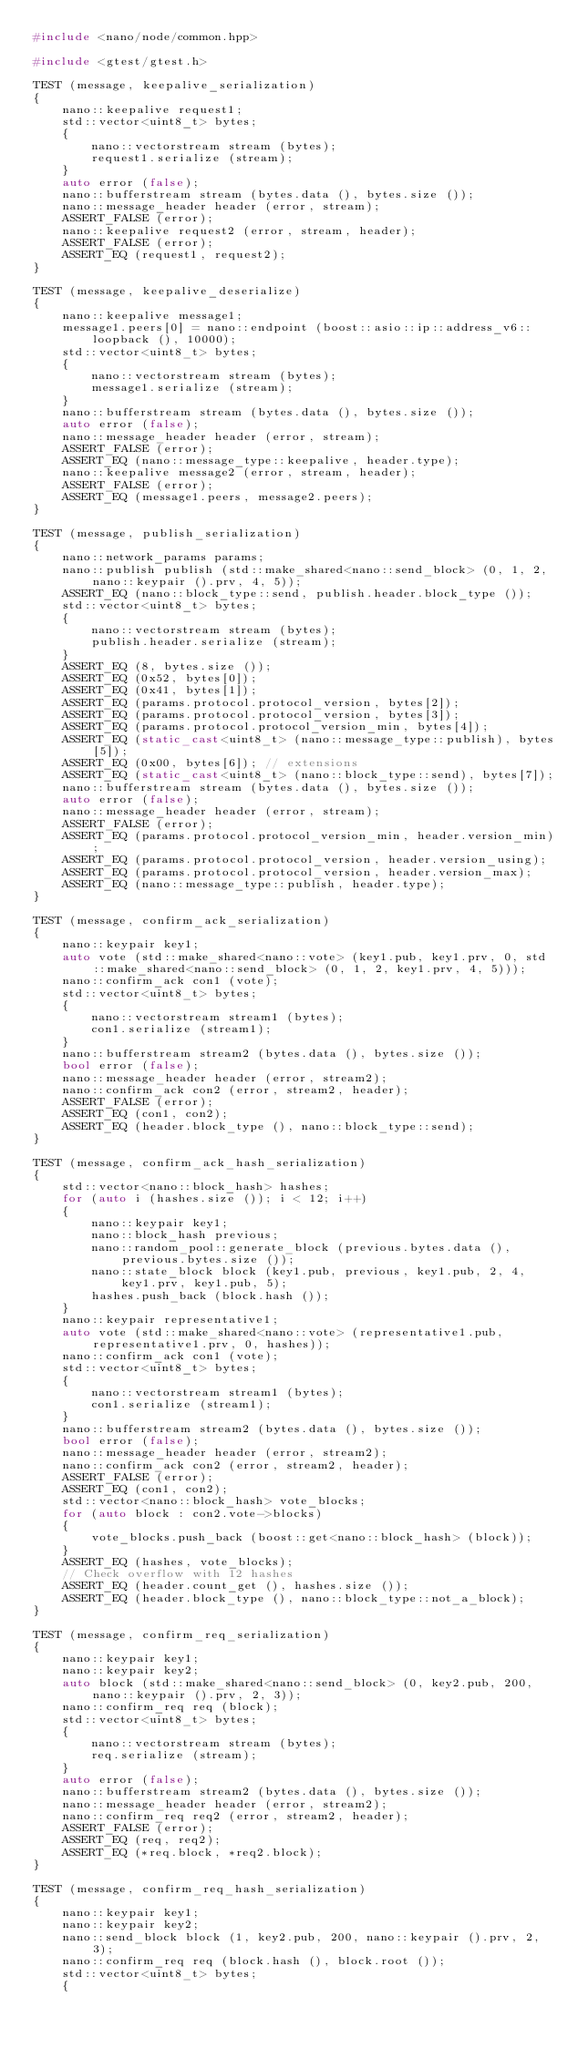Convert code to text. <code><loc_0><loc_0><loc_500><loc_500><_C++_>#include <nano/node/common.hpp>

#include <gtest/gtest.h>

TEST (message, keepalive_serialization)
{
	nano::keepalive request1;
	std::vector<uint8_t> bytes;
	{
		nano::vectorstream stream (bytes);
		request1.serialize (stream);
	}
	auto error (false);
	nano::bufferstream stream (bytes.data (), bytes.size ());
	nano::message_header header (error, stream);
	ASSERT_FALSE (error);
	nano::keepalive request2 (error, stream, header);
	ASSERT_FALSE (error);
	ASSERT_EQ (request1, request2);
}

TEST (message, keepalive_deserialize)
{
	nano::keepalive message1;
	message1.peers[0] = nano::endpoint (boost::asio::ip::address_v6::loopback (), 10000);
	std::vector<uint8_t> bytes;
	{
		nano::vectorstream stream (bytes);
		message1.serialize (stream);
	}
	nano::bufferstream stream (bytes.data (), bytes.size ());
	auto error (false);
	nano::message_header header (error, stream);
	ASSERT_FALSE (error);
	ASSERT_EQ (nano::message_type::keepalive, header.type);
	nano::keepalive message2 (error, stream, header);
	ASSERT_FALSE (error);
	ASSERT_EQ (message1.peers, message2.peers);
}

TEST (message, publish_serialization)
{
	nano::network_params params;
	nano::publish publish (std::make_shared<nano::send_block> (0, 1, 2, nano::keypair ().prv, 4, 5));
	ASSERT_EQ (nano::block_type::send, publish.header.block_type ());
	std::vector<uint8_t> bytes;
	{
		nano::vectorstream stream (bytes);
		publish.header.serialize (stream);
	}
	ASSERT_EQ (8, bytes.size ());
	ASSERT_EQ (0x52, bytes[0]);
	ASSERT_EQ (0x41, bytes[1]);
	ASSERT_EQ (params.protocol.protocol_version, bytes[2]);
	ASSERT_EQ (params.protocol.protocol_version, bytes[3]);
	ASSERT_EQ (params.protocol.protocol_version_min, bytes[4]);
	ASSERT_EQ (static_cast<uint8_t> (nano::message_type::publish), bytes[5]);
	ASSERT_EQ (0x00, bytes[6]); // extensions
	ASSERT_EQ (static_cast<uint8_t> (nano::block_type::send), bytes[7]);
	nano::bufferstream stream (bytes.data (), bytes.size ());
	auto error (false);
	nano::message_header header (error, stream);
	ASSERT_FALSE (error);
	ASSERT_EQ (params.protocol.protocol_version_min, header.version_min);
	ASSERT_EQ (params.protocol.protocol_version, header.version_using);
	ASSERT_EQ (params.protocol.protocol_version, header.version_max);
	ASSERT_EQ (nano::message_type::publish, header.type);
}

TEST (message, confirm_ack_serialization)
{
	nano::keypair key1;
	auto vote (std::make_shared<nano::vote> (key1.pub, key1.prv, 0, std::make_shared<nano::send_block> (0, 1, 2, key1.prv, 4, 5)));
	nano::confirm_ack con1 (vote);
	std::vector<uint8_t> bytes;
	{
		nano::vectorstream stream1 (bytes);
		con1.serialize (stream1);
	}
	nano::bufferstream stream2 (bytes.data (), bytes.size ());
	bool error (false);
	nano::message_header header (error, stream2);
	nano::confirm_ack con2 (error, stream2, header);
	ASSERT_FALSE (error);
	ASSERT_EQ (con1, con2);
	ASSERT_EQ (header.block_type (), nano::block_type::send);
}

TEST (message, confirm_ack_hash_serialization)
{
	std::vector<nano::block_hash> hashes;
	for (auto i (hashes.size ()); i < 12; i++)
	{
		nano::keypair key1;
		nano::block_hash previous;
		nano::random_pool::generate_block (previous.bytes.data (), previous.bytes.size ());
		nano::state_block block (key1.pub, previous, key1.pub, 2, 4, key1.prv, key1.pub, 5);
		hashes.push_back (block.hash ());
	}
	nano::keypair representative1;
	auto vote (std::make_shared<nano::vote> (representative1.pub, representative1.prv, 0, hashes));
	nano::confirm_ack con1 (vote);
	std::vector<uint8_t> bytes;
	{
		nano::vectorstream stream1 (bytes);
		con1.serialize (stream1);
	}
	nano::bufferstream stream2 (bytes.data (), bytes.size ());
	bool error (false);
	nano::message_header header (error, stream2);
	nano::confirm_ack con2 (error, stream2, header);
	ASSERT_FALSE (error);
	ASSERT_EQ (con1, con2);
	std::vector<nano::block_hash> vote_blocks;
	for (auto block : con2.vote->blocks)
	{
		vote_blocks.push_back (boost::get<nano::block_hash> (block));
	}
	ASSERT_EQ (hashes, vote_blocks);
	// Check overflow with 12 hashes
	ASSERT_EQ (header.count_get (), hashes.size ());
	ASSERT_EQ (header.block_type (), nano::block_type::not_a_block);
}

TEST (message, confirm_req_serialization)
{
	nano::keypair key1;
	nano::keypair key2;
	auto block (std::make_shared<nano::send_block> (0, key2.pub, 200, nano::keypair ().prv, 2, 3));
	nano::confirm_req req (block);
	std::vector<uint8_t> bytes;
	{
		nano::vectorstream stream (bytes);
		req.serialize (stream);
	}
	auto error (false);
	nano::bufferstream stream2 (bytes.data (), bytes.size ());
	nano::message_header header (error, stream2);
	nano::confirm_req req2 (error, stream2, header);
	ASSERT_FALSE (error);
	ASSERT_EQ (req, req2);
	ASSERT_EQ (*req.block, *req2.block);
}

TEST (message, confirm_req_hash_serialization)
{
	nano::keypair key1;
	nano::keypair key2;
	nano::send_block block (1, key2.pub, 200, nano::keypair ().prv, 2, 3);
	nano::confirm_req req (block.hash (), block.root ());
	std::vector<uint8_t> bytes;
	{</code> 